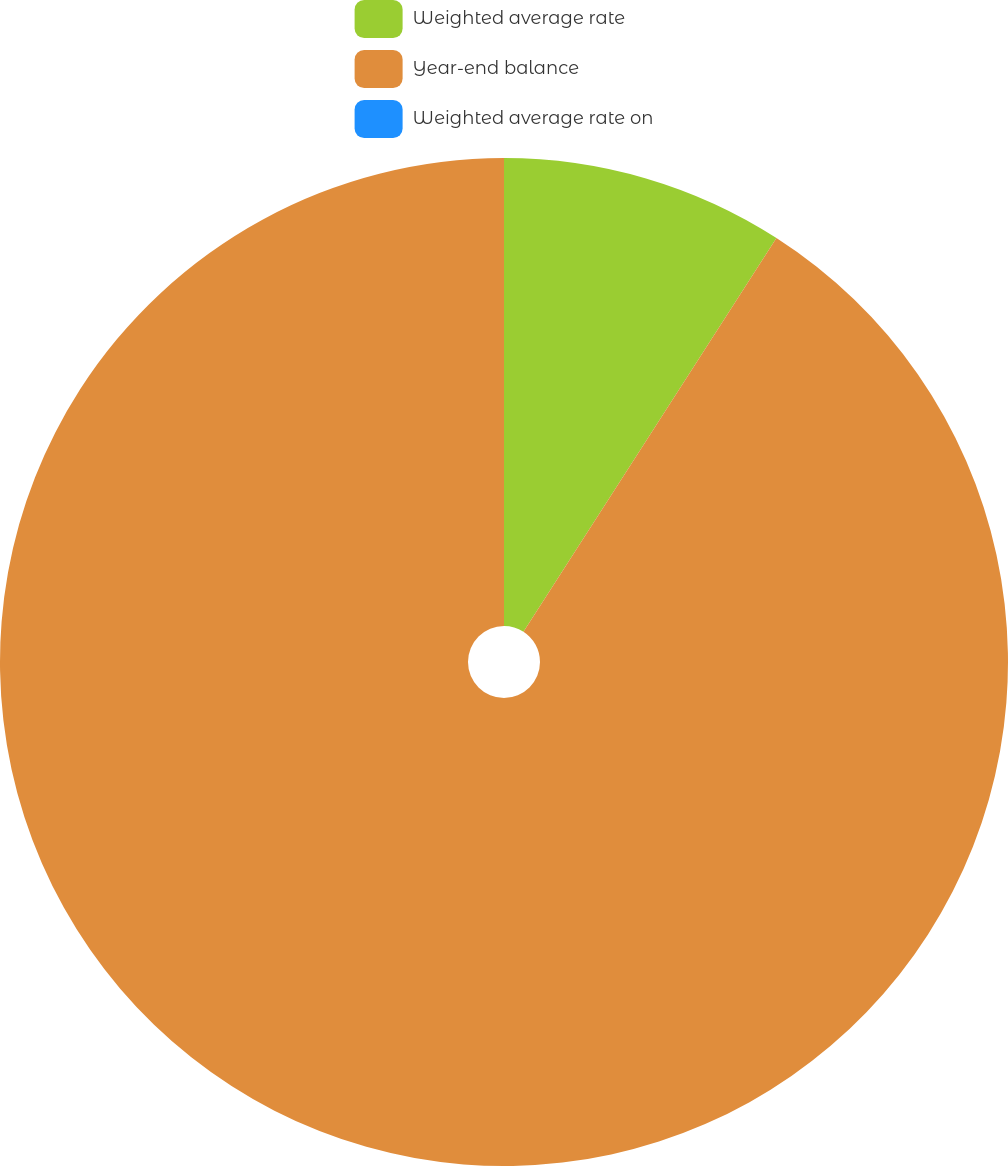Convert chart to OTSL. <chart><loc_0><loc_0><loc_500><loc_500><pie_chart><fcel>Weighted average rate<fcel>Year-end balance<fcel>Weighted average rate on<nl><fcel>9.09%<fcel>90.91%<fcel>0.0%<nl></chart> 